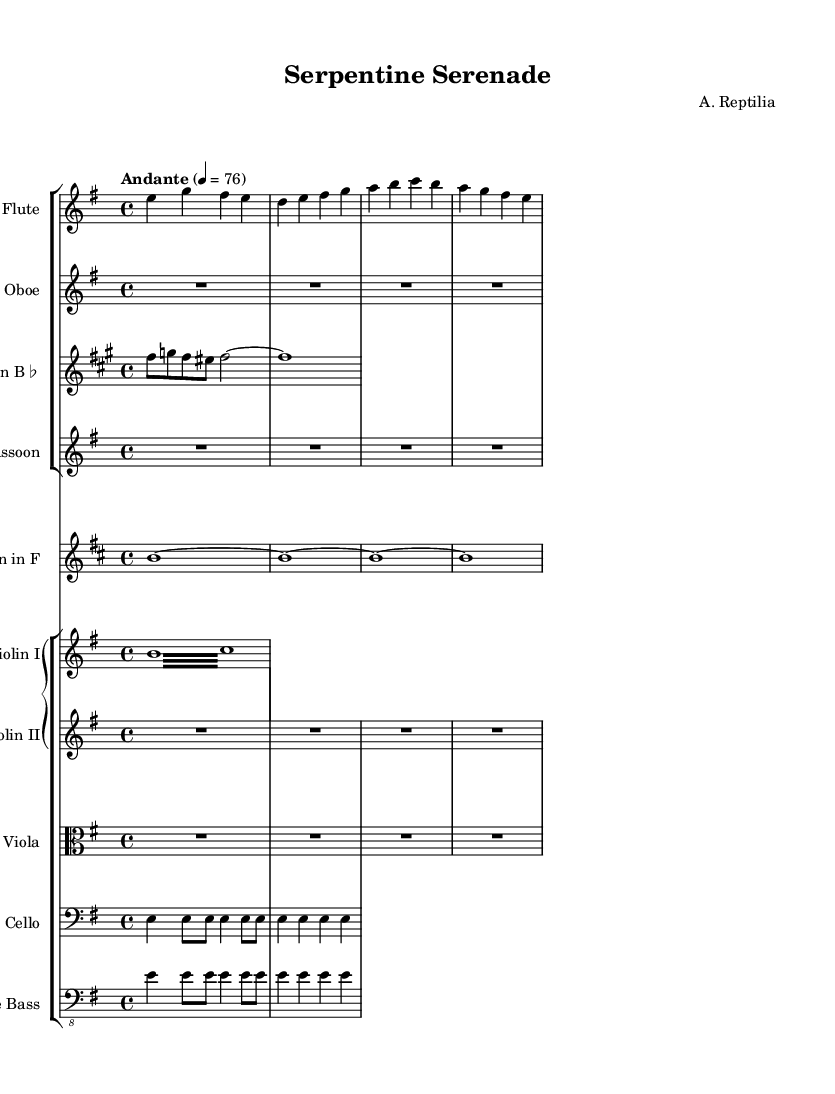What is the key signature of this music? The key signature is indicated by the number of sharps or flats included in the beginning. In this case, the sheet music states "e minor," which contains one sharp (F sharp).
Answer: E minor What is the time signature of this music? The time signature appears at the beginning of the piece, represented by "4/4." This shows that there are four beats in each measure and a quarter note gets one beat.
Answer: Four-four What is the tempo marking of this music? The tempo marking indicates the speed of the piece and is found just above the staff. Here it reads "Andante," suggesting a moderately slow pace.
Answer: Andante How many measures are in the flute part? To determine the number of measures, count the grouping of notes between the vertical lines separating them. The flute part has four measures total.
Answer: Four Which instruments have rests in the first measure? By reviewing the first measures of each instrument part, it is clear that both the oboe and bassoon have rests indicated by "R1*4." This signifies they don’t play in that measure.
Answer: Oboe, Bassoon What motif can be associated with the overall theme of this symphony? Looking closely at how the melodies and harmonies are constructed, one can deduce the music evokes serpent-like movements with flowing lines and undulating rhythms, creating a nature-inspired motif.
Answer: Serpentine motif How is the cello part constructed in the first section? Analyzing the notes in the cello part reveals a repetitive rhythmic pattern (shown by the eighth notes followed by quarter notes), contributing to a crawling sensation that could be interpreted as reptilian. This construction draws parallels with snake movements.
Answer: Repetitive rhythmic pattern 